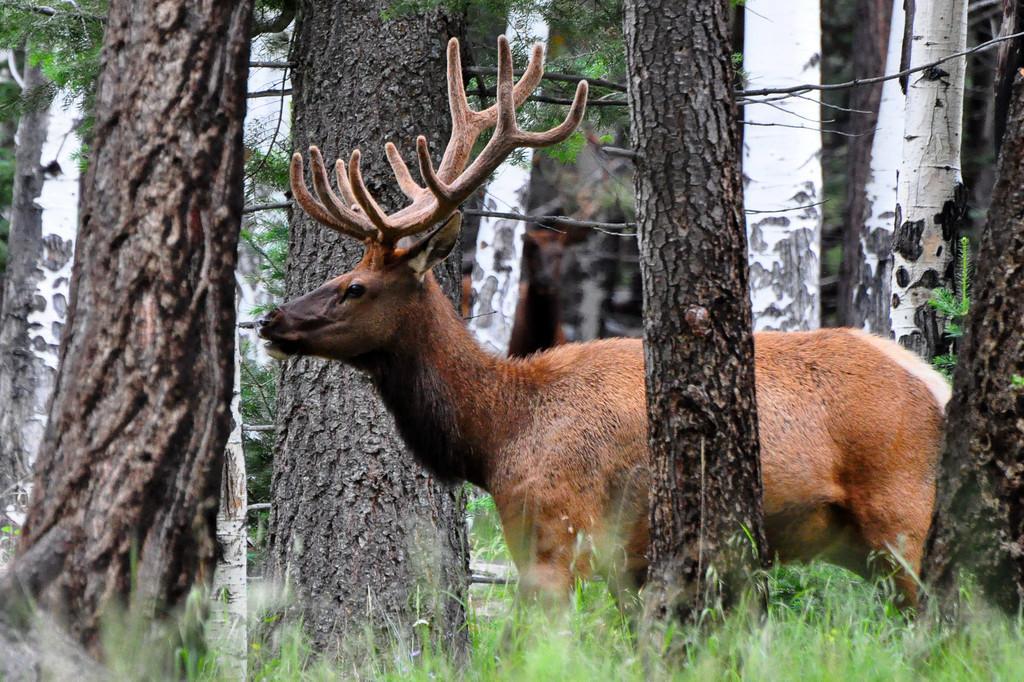In one or two sentences, can you explain what this image depicts? In this image in the foreground there is one animal and in the background there are some trees, at the bottom there is grass. 